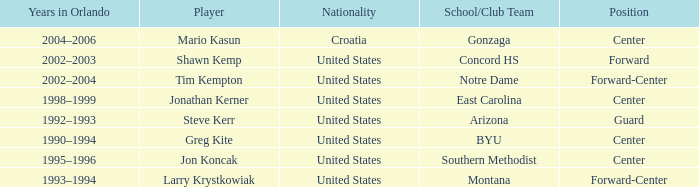What years in orlando have the United States as the nationality, and montana as the school/club team? 1993–1994. 